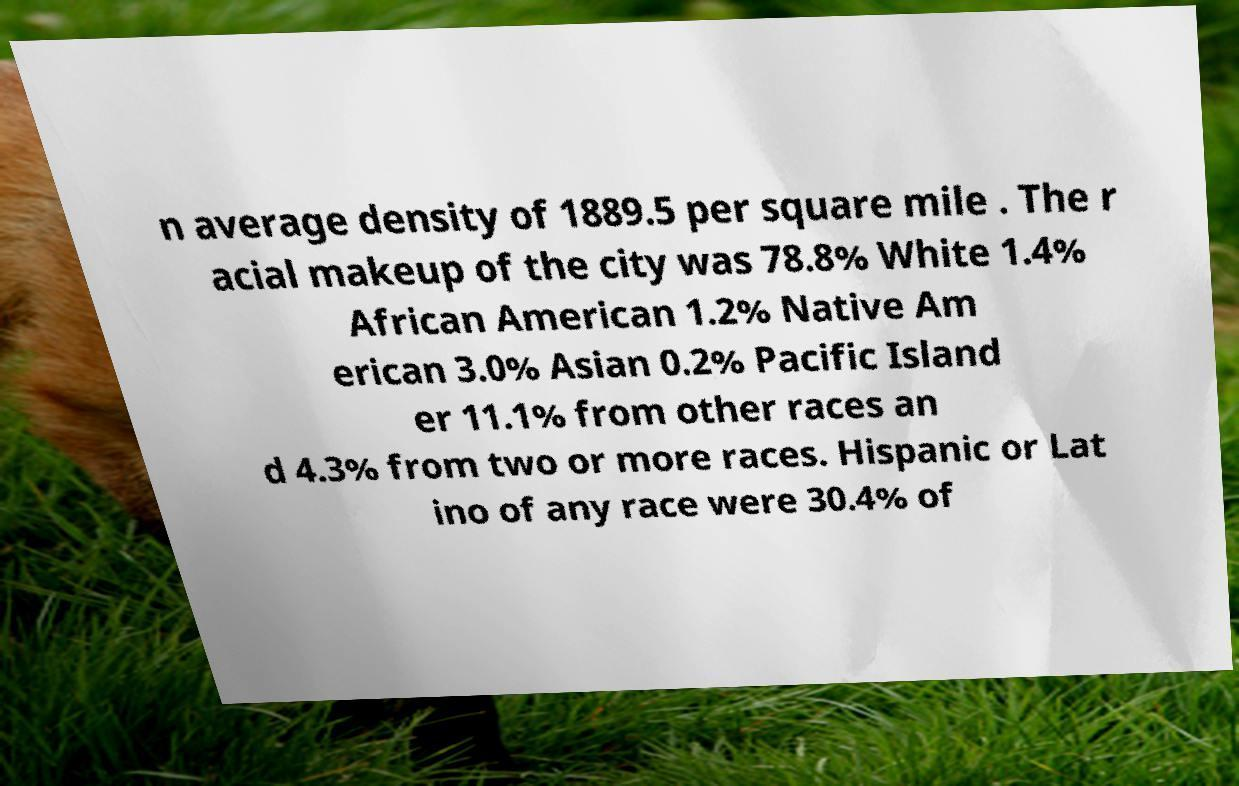What messages or text are displayed in this image? I need them in a readable, typed format. n average density of 1889.5 per square mile . The r acial makeup of the city was 78.8% White 1.4% African American 1.2% Native Am erican 3.0% Asian 0.2% Pacific Island er 11.1% from other races an d 4.3% from two or more races. Hispanic or Lat ino of any race were 30.4% of 